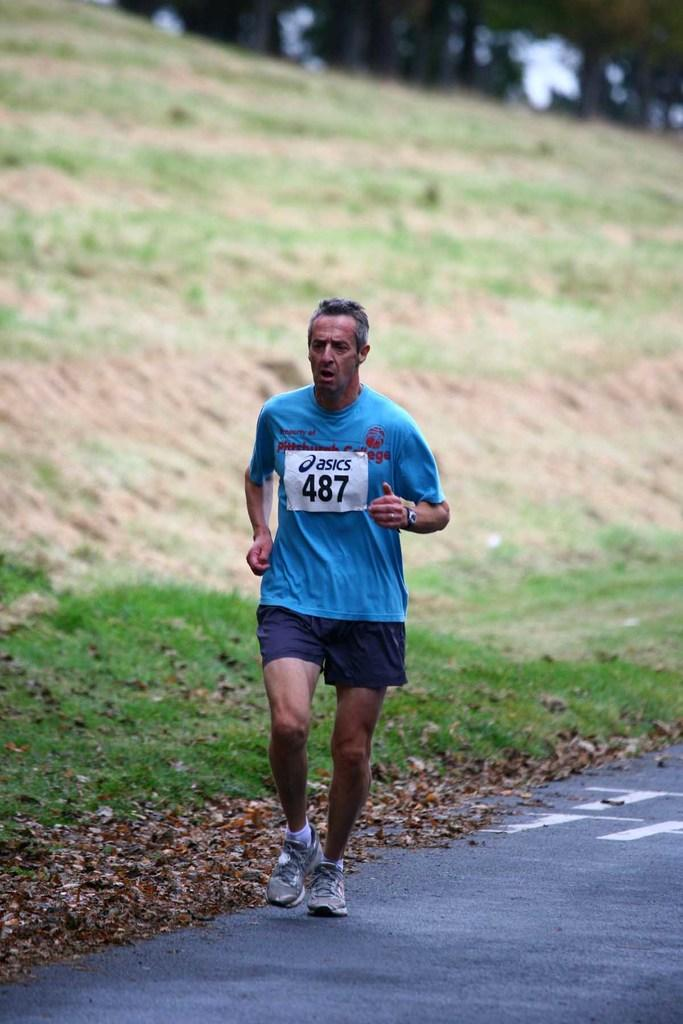What is the man in the image doing? The man is running on the road. What can be seen on the ground in the image? Dried leaves are lying on the ground. What type of vegetation is visible in the image? There is grass visible in the image. Where is the scene likely taking place? The scene appears to be on a hill. How is the background of the image depicted? The background is blurry. What organization is the pig associated with in the image? There is no pig present in the image, so it is not possible to associate it with any organization. 